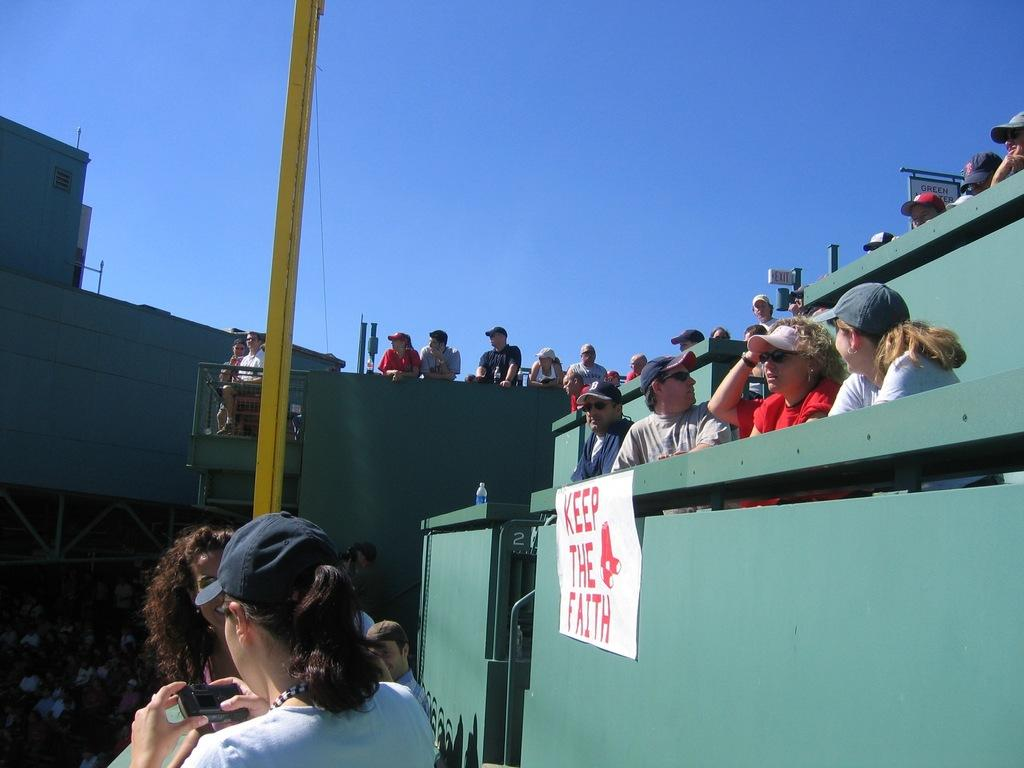How many people can be seen in the image? There are a few people in the image. What is the yellow-colored object with a wire in the image? There is a yellow-colored pole with a wire in the image. What type of structure is visible in the image? There is a wall visible in the image. What is attached to the wall in the image? There is a poster in the image. What is the object made of glass in the image? There is a bottle in the image. What are the flat, rectangular objects in the image? There are boards in the image. What part of the natural environment is visible in the image? The sky is visible in the image. What type of plate is being used by the brothers in the image? There are no brothers or plates present in the image. What season is depicted in the image? The image does not depict a specific season; it only shows a wall, a poster, a bottle, and boards. 